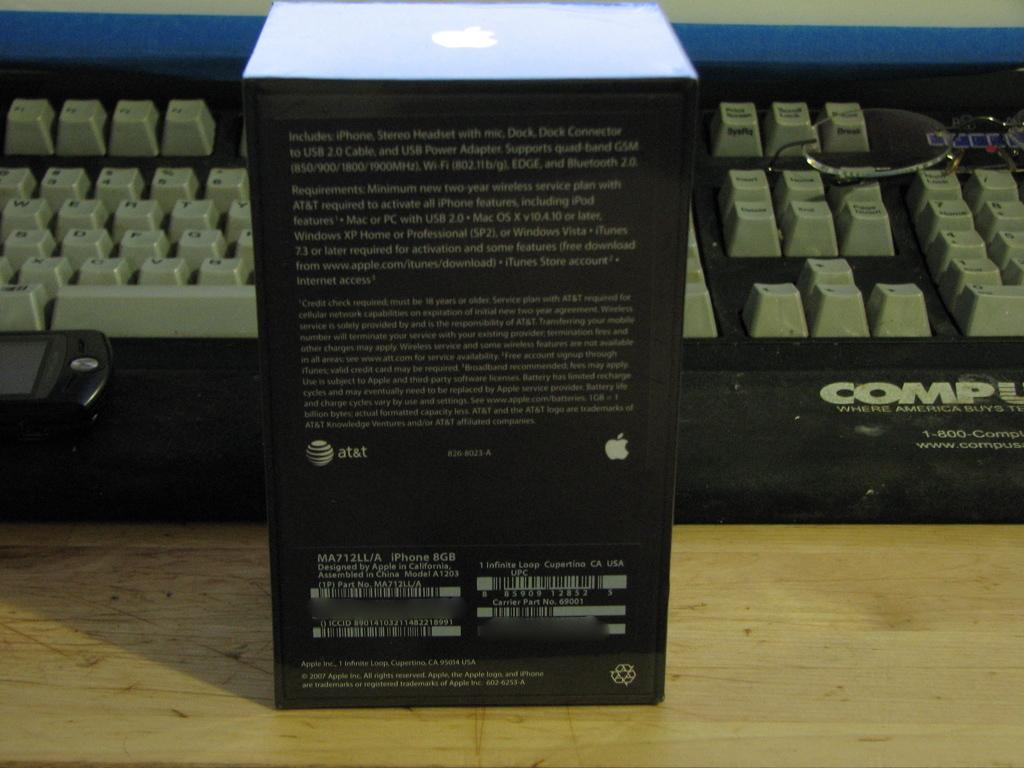<image>
Present a compact description of the photo's key features. a box in front of a keyboard with the word COMP on it 